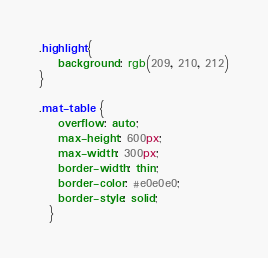Convert code to text. <code><loc_0><loc_0><loc_500><loc_500><_CSS_>.highlight{
    background: rgb(209, 210, 212)
}

.mat-table {
    overflow: auto;
    max-height: 600px;
    max-width: 300px;
    border-width: thin;
    border-color: #e0e0e0;
    border-style: solid;
  }
</code> 